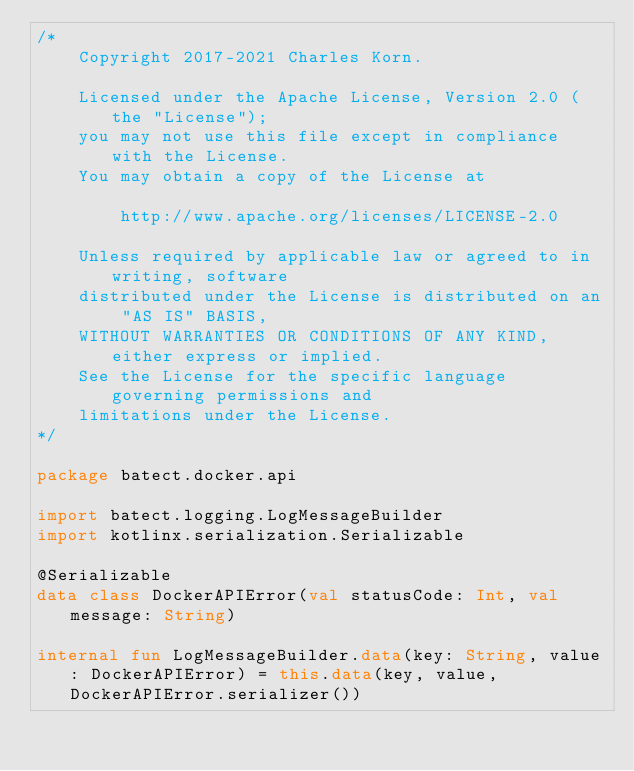Convert code to text. <code><loc_0><loc_0><loc_500><loc_500><_Kotlin_>/*
    Copyright 2017-2021 Charles Korn.

    Licensed under the Apache License, Version 2.0 (the "License");
    you may not use this file except in compliance with the License.
    You may obtain a copy of the License at

        http://www.apache.org/licenses/LICENSE-2.0

    Unless required by applicable law or agreed to in writing, software
    distributed under the License is distributed on an "AS IS" BASIS,
    WITHOUT WARRANTIES OR CONDITIONS OF ANY KIND, either express or implied.
    See the License for the specific language governing permissions and
    limitations under the License.
*/

package batect.docker.api

import batect.logging.LogMessageBuilder
import kotlinx.serialization.Serializable

@Serializable
data class DockerAPIError(val statusCode: Int, val message: String)

internal fun LogMessageBuilder.data(key: String, value: DockerAPIError) = this.data(key, value, DockerAPIError.serializer())
</code> 